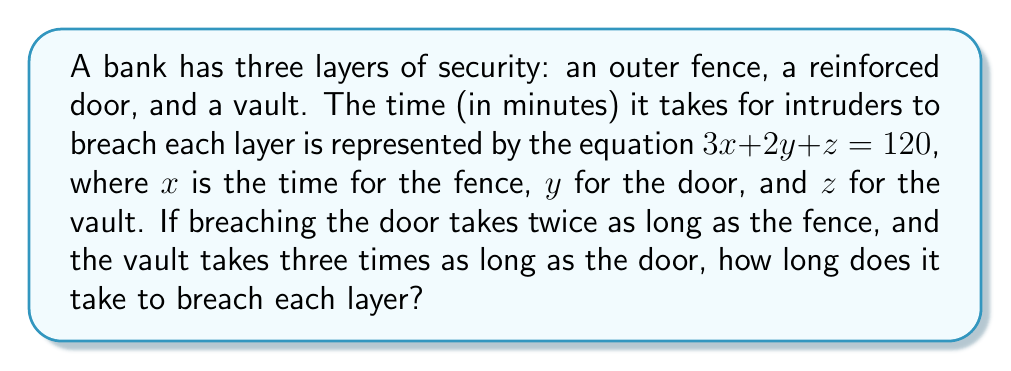Can you solve this math problem? Let's solve this step-by-step:

1) We're given that $3x + 2y + z = 120$

2) We're also told that:
   - The door ($y$) takes twice as long as the fence ($x$): $y = 2x$
   - The vault ($z$) takes three times as long as the door ($y$): $z = 3y$

3) Let's substitute these relationships into our original equation:
   $3x + 2(2x) + 3(2x) = 120$

4) Simplify:
   $3x + 4x + 6x = 120$
   $13x = 120$

5) Solve for $x$:
   $x = 120 \div 13 \approx 9.23$ minutes

6) Now we can find $y$ and $z$:
   $y = 2x = 2(9.23) \approx 18.46$ minutes
   $z = 3y = 3(18.46) \approx 55.38$ minutes

7) Round to the nearest minute:
   $x = 9$ minutes (fence)
   $y = 18$ minutes (door)
   $z = 55$ minutes (vault)
Answer: Fence: 9 minutes, Door: 18 minutes, Vault: 55 minutes 